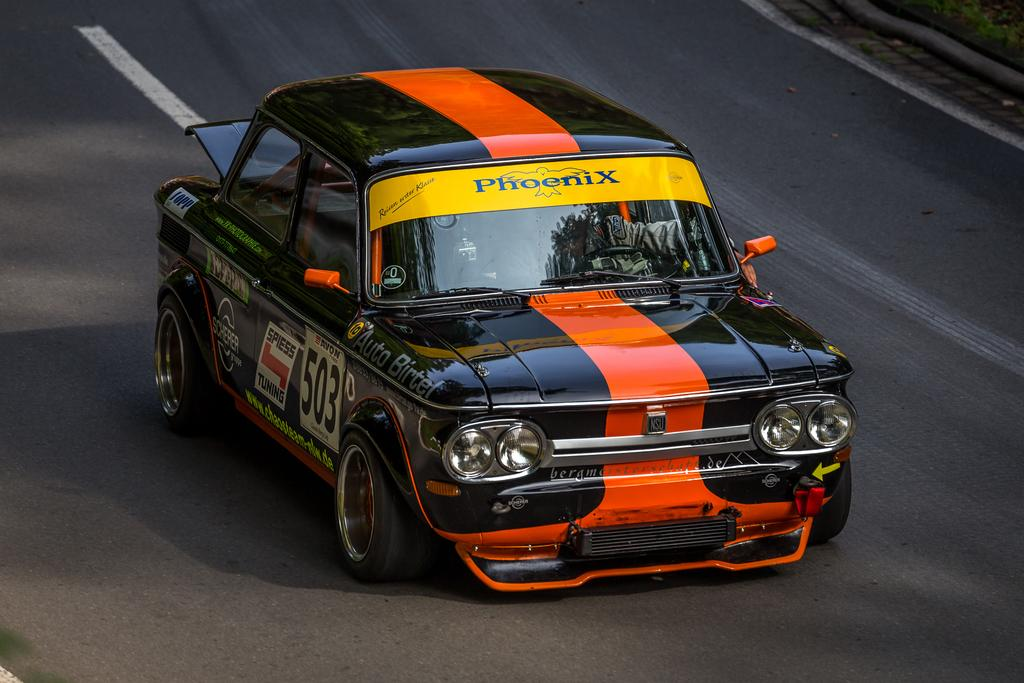What is the main subject of the image? The main subject of the image is a car. Where is the car located in the image? The car is on the road in the image. What type of oatmeal is being cooked in the car's engine in the image? There is no oatmeal or cooking activity present in the image; it features a car on the road. How many eggs can be seen in the car's interior in the image? There are no eggs visible in the car's interior in the image. 